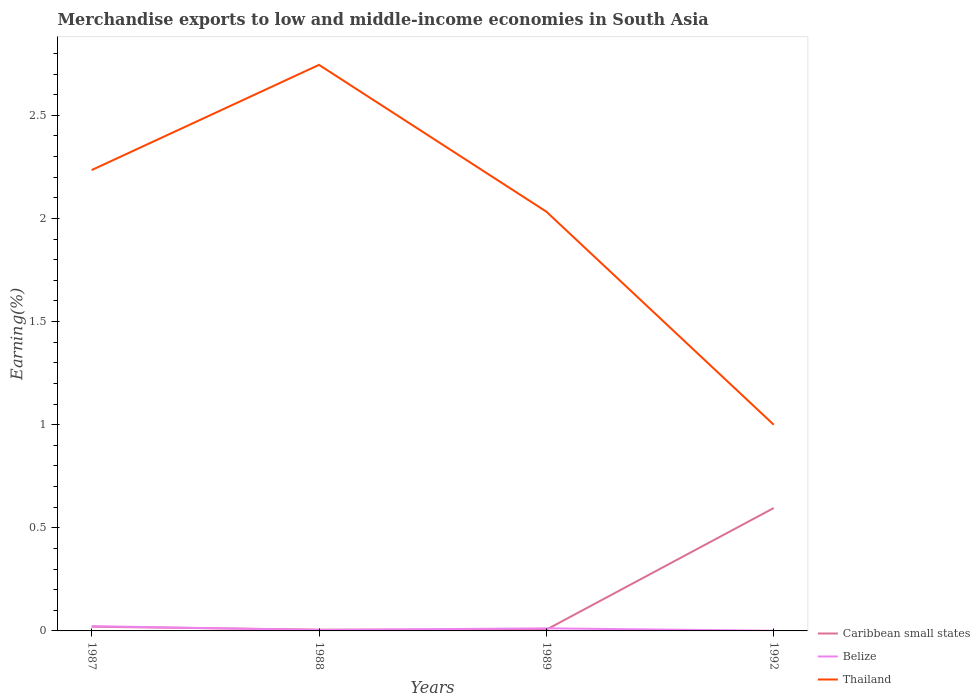Is the number of lines equal to the number of legend labels?
Your answer should be very brief. Yes. Across all years, what is the maximum percentage of amount earned from merchandise exports in Belize?
Offer a terse response. 0. What is the total percentage of amount earned from merchandise exports in Belize in the graph?
Your response must be concise. 0.01. What is the difference between the highest and the second highest percentage of amount earned from merchandise exports in Belize?
Make the answer very short. 0.02. Is the percentage of amount earned from merchandise exports in Belize strictly greater than the percentage of amount earned from merchandise exports in Thailand over the years?
Keep it short and to the point. Yes. How many years are there in the graph?
Your answer should be very brief. 4. Does the graph contain grids?
Ensure brevity in your answer.  No. Where does the legend appear in the graph?
Provide a succinct answer. Bottom right. How many legend labels are there?
Your answer should be compact. 3. What is the title of the graph?
Make the answer very short. Merchandise exports to low and middle-income economies in South Asia. Does "Bermuda" appear as one of the legend labels in the graph?
Offer a terse response. No. What is the label or title of the Y-axis?
Provide a succinct answer. Earning(%). What is the Earning(%) of Caribbean small states in 1987?
Your answer should be very brief. 0.02. What is the Earning(%) of Belize in 1987?
Offer a very short reply. 0.02. What is the Earning(%) of Thailand in 1987?
Offer a very short reply. 2.23. What is the Earning(%) of Caribbean small states in 1988?
Offer a very short reply. 0.01. What is the Earning(%) of Belize in 1988?
Offer a very short reply. 0. What is the Earning(%) in Thailand in 1988?
Offer a terse response. 2.74. What is the Earning(%) in Caribbean small states in 1989?
Keep it short and to the point. 0.01. What is the Earning(%) of Belize in 1989?
Your answer should be very brief. 0.01. What is the Earning(%) of Thailand in 1989?
Your answer should be compact. 2.03. What is the Earning(%) of Caribbean small states in 1992?
Provide a succinct answer. 0.6. What is the Earning(%) of Belize in 1992?
Offer a terse response. 0. What is the Earning(%) in Thailand in 1992?
Give a very brief answer. 1. Across all years, what is the maximum Earning(%) of Caribbean small states?
Give a very brief answer. 0.6. Across all years, what is the maximum Earning(%) in Belize?
Your answer should be very brief. 0.02. Across all years, what is the maximum Earning(%) of Thailand?
Your response must be concise. 2.74. Across all years, what is the minimum Earning(%) of Caribbean small states?
Offer a very short reply. 0.01. Across all years, what is the minimum Earning(%) in Belize?
Make the answer very short. 0. Across all years, what is the minimum Earning(%) in Thailand?
Offer a very short reply. 1. What is the total Earning(%) in Caribbean small states in the graph?
Ensure brevity in your answer.  0.63. What is the total Earning(%) of Belize in the graph?
Ensure brevity in your answer.  0.04. What is the total Earning(%) in Thailand in the graph?
Offer a terse response. 8.01. What is the difference between the Earning(%) in Caribbean small states in 1987 and that in 1988?
Keep it short and to the point. 0.01. What is the difference between the Earning(%) of Belize in 1987 and that in 1988?
Offer a very short reply. 0.02. What is the difference between the Earning(%) of Thailand in 1987 and that in 1988?
Provide a succinct answer. -0.51. What is the difference between the Earning(%) in Caribbean small states in 1987 and that in 1989?
Offer a terse response. 0.01. What is the difference between the Earning(%) in Belize in 1987 and that in 1989?
Your answer should be very brief. 0.01. What is the difference between the Earning(%) of Thailand in 1987 and that in 1989?
Provide a succinct answer. 0.2. What is the difference between the Earning(%) of Caribbean small states in 1987 and that in 1992?
Your answer should be compact. -0.58. What is the difference between the Earning(%) in Belize in 1987 and that in 1992?
Provide a short and direct response. 0.02. What is the difference between the Earning(%) in Thailand in 1987 and that in 1992?
Make the answer very short. 1.23. What is the difference between the Earning(%) of Caribbean small states in 1988 and that in 1989?
Offer a terse response. -0. What is the difference between the Earning(%) of Belize in 1988 and that in 1989?
Keep it short and to the point. -0.01. What is the difference between the Earning(%) of Thailand in 1988 and that in 1989?
Ensure brevity in your answer.  0.71. What is the difference between the Earning(%) of Caribbean small states in 1988 and that in 1992?
Keep it short and to the point. -0.59. What is the difference between the Earning(%) in Belize in 1988 and that in 1992?
Give a very brief answer. 0. What is the difference between the Earning(%) in Thailand in 1988 and that in 1992?
Offer a very short reply. 1.75. What is the difference between the Earning(%) of Caribbean small states in 1989 and that in 1992?
Ensure brevity in your answer.  -0.59. What is the difference between the Earning(%) in Belize in 1989 and that in 1992?
Keep it short and to the point. 0.01. What is the difference between the Earning(%) in Thailand in 1989 and that in 1992?
Your response must be concise. 1.03. What is the difference between the Earning(%) of Caribbean small states in 1987 and the Earning(%) of Belize in 1988?
Your answer should be very brief. 0.02. What is the difference between the Earning(%) in Caribbean small states in 1987 and the Earning(%) in Thailand in 1988?
Provide a succinct answer. -2.72. What is the difference between the Earning(%) in Belize in 1987 and the Earning(%) in Thailand in 1988?
Your answer should be very brief. -2.72. What is the difference between the Earning(%) of Caribbean small states in 1987 and the Earning(%) of Belize in 1989?
Your response must be concise. 0.01. What is the difference between the Earning(%) in Caribbean small states in 1987 and the Earning(%) in Thailand in 1989?
Offer a very short reply. -2.01. What is the difference between the Earning(%) in Belize in 1987 and the Earning(%) in Thailand in 1989?
Your response must be concise. -2.01. What is the difference between the Earning(%) of Caribbean small states in 1987 and the Earning(%) of Belize in 1992?
Offer a very short reply. 0.02. What is the difference between the Earning(%) in Caribbean small states in 1987 and the Earning(%) in Thailand in 1992?
Your answer should be compact. -0.98. What is the difference between the Earning(%) in Belize in 1987 and the Earning(%) in Thailand in 1992?
Offer a terse response. -0.98. What is the difference between the Earning(%) of Caribbean small states in 1988 and the Earning(%) of Belize in 1989?
Offer a terse response. -0.01. What is the difference between the Earning(%) of Caribbean small states in 1988 and the Earning(%) of Thailand in 1989?
Offer a terse response. -2.03. What is the difference between the Earning(%) in Belize in 1988 and the Earning(%) in Thailand in 1989?
Your answer should be very brief. -2.03. What is the difference between the Earning(%) in Caribbean small states in 1988 and the Earning(%) in Belize in 1992?
Offer a very short reply. 0.01. What is the difference between the Earning(%) of Caribbean small states in 1988 and the Earning(%) of Thailand in 1992?
Your response must be concise. -0.99. What is the difference between the Earning(%) of Belize in 1988 and the Earning(%) of Thailand in 1992?
Your response must be concise. -1. What is the difference between the Earning(%) in Caribbean small states in 1989 and the Earning(%) in Belize in 1992?
Make the answer very short. 0.01. What is the difference between the Earning(%) in Caribbean small states in 1989 and the Earning(%) in Thailand in 1992?
Provide a short and direct response. -0.99. What is the difference between the Earning(%) of Belize in 1989 and the Earning(%) of Thailand in 1992?
Give a very brief answer. -0.99. What is the average Earning(%) of Caribbean small states per year?
Provide a short and direct response. 0.16. What is the average Earning(%) in Belize per year?
Your answer should be compact. 0.01. What is the average Earning(%) of Thailand per year?
Keep it short and to the point. 2. In the year 1987, what is the difference between the Earning(%) of Caribbean small states and Earning(%) of Belize?
Give a very brief answer. -0. In the year 1987, what is the difference between the Earning(%) of Caribbean small states and Earning(%) of Thailand?
Your response must be concise. -2.21. In the year 1987, what is the difference between the Earning(%) of Belize and Earning(%) of Thailand?
Provide a succinct answer. -2.21. In the year 1988, what is the difference between the Earning(%) in Caribbean small states and Earning(%) in Belize?
Your answer should be compact. 0. In the year 1988, what is the difference between the Earning(%) of Caribbean small states and Earning(%) of Thailand?
Keep it short and to the point. -2.74. In the year 1988, what is the difference between the Earning(%) of Belize and Earning(%) of Thailand?
Ensure brevity in your answer.  -2.74. In the year 1989, what is the difference between the Earning(%) in Caribbean small states and Earning(%) in Belize?
Offer a terse response. -0.01. In the year 1989, what is the difference between the Earning(%) of Caribbean small states and Earning(%) of Thailand?
Your response must be concise. -2.03. In the year 1989, what is the difference between the Earning(%) of Belize and Earning(%) of Thailand?
Make the answer very short. -2.02. In the year 1992, what is the difference between the Earning(%) of Caribbean small states and Earning(%) of Belize?
Offer a terse response. 0.6. In the year 1992, what is the difference between the Earning(%) in Caribbean small states and Earning(%) in Thailand?
Your answer should be compact. -0.4. In the year 1992, what is the difference between the Earning(%) in Belize and Earning(%) in Thailand?
Provide a succinct answer. -1. What is the ratio of the Earning(%) of Caribbean small states in 1987 to that in 1988?
Make the answer very short. 3.38. What is the ratio of the Earning(%) of Belize in 1987 to that in 1988?
Your answer should be compact. 5.18. What is the ratio of the Earning(%) of Thailand in 1987 to that in 1988?
Your answer should be very brief. 0.81. What is the ratio of the Earning(%) of Caribbean small states in 1987 to that in 1989?
Offer a terse response. 3.32. What is the ratio of the Earning(%) in Belize in 1987 to that in 1989?
Your answer should be compact. 1.85. What is the ratio of the Earning(%) of Thailand in 1987 to that in 1989?
Your answer should be very brief. 1.1. What is the ratio of the Earning(%) in Caribbean small states in 1987 to that in 1992?
Your answer should be very brief. 0.03. What is the ratio of the Earning(%) of Belize in 1987 to that in 1992?
Your answer should be very brief. 29.01. What is the ratio of the Earning(%) of Thailand in 1987 to that in 1992?
Keep it short and to the point. 2.24. What is the ratio of the Earning(%) of Caribbean small states in 1988 to that in 1989?
Provide a short and direct response. 0.98. What is the ratio of the Earning(%) of Belize in 1988 to that in 1989?
Keep it short and to the point. 0.36. What is the ratio of the Earning(%) of Thailand in 1988 to that in 1989?
Ensure brevity in your answer.  1.35. What is the ratio of the Earning(%) in Caribbean small states in 1988 to that in 1992?
Ensure brevity in your answer.  0.01. What is the ratio of the Earning(%) in Belize in 1988 to that in 1992?
Give a very brief answer. 5.6. What is the ratio of the Earning(%) in Thailand in 1988 to that in 1992?
Give a very brief answer. 2.75. What is the ratio of the Earning(%) in Caribbean small states in 1989 to that in 1992?
Your response must be concise. 0.01. What is the ratio of the Earning(%) in Belize in 1989 to that in 1992?
Provide a succinct answer. 15.67. What is the ratio of the Earning(%) in Thailand in 1989 to that in 1992?
Your response must be concise. 2.03. What is the difference between the highest and the second highest Earning(%) in Caribbean small states?
Offer a very short reply. 0.58. What is the difference between the highest and the second highest Earning(%) in Belize?
Give a very brief answer. 0.01. What is the difference between the highest and the second highest Earning(%) of Thailand?
Your answer should be very brief. 0.51. What is the difference between the highest and the lowest Earning(%) in Caribbean small states?
Provide a succinct answer. 0.59. What is the difference between the highest and the lowest Earning(%) of Belize?
Ensure brevity in your answer.  0.02. What is the difference between the highest and the lowest Earning(%) in Thailand?
Make the answer very short. 1.75. 